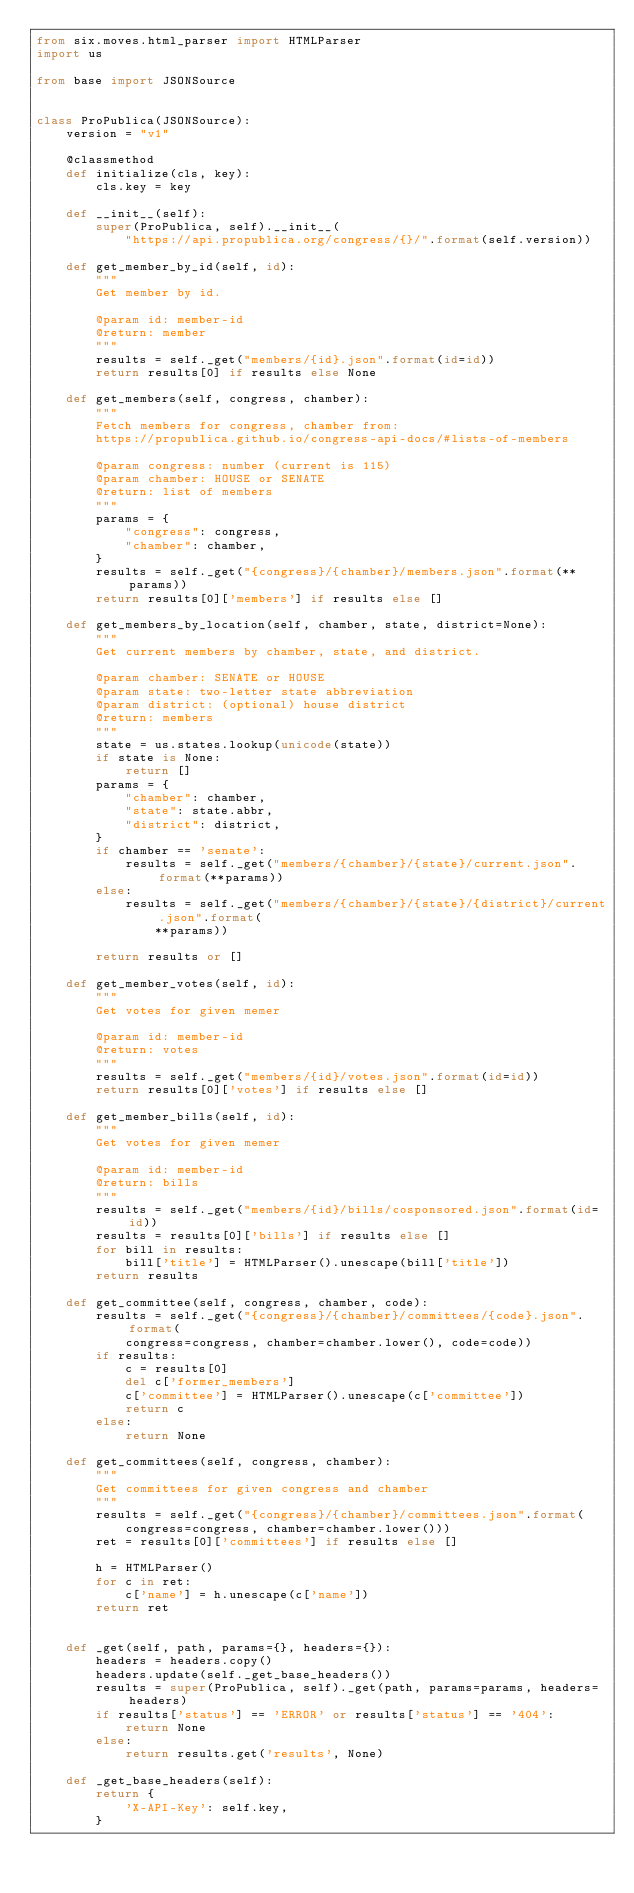Convert code to text. <code><loc_0><loc_0><loc_500><loc_500><_Python_>from six.moves.html_parser import HTMLParser
import us

from base import JSONSource


class ProPublica(JSONSource):
    version = "v1"

    @classmethod
    def initialize(cls, key):
        cls.key = key

    def __init__(self):
        super(ProPublica, self).__init__(
            "https://api.propublica.org/congress/{}/".format(self.version))

    def get_member_by_id(self, id):
        """
        Get member by id.

        @param id: member-id
        @return: member
        """
        results = self._get("members/{id}.json".format(id=id))
        return results[0] if results else None

    def get_members(self, congress, chamber):
        """
        Fetch members for congress, chamber from:
        https://propublica.github.io/congress-api-docs/#lists-of-members

        @param congress: number (current is 115)
        @param chamber: HOUSE or SENATE
        @return: list of members
        """
        params = {
            "congress": congress,
            "chamber": chamber,
        }
        results = self._get("{congress}/{chamber}/members.json".format(**params))
        return results[0]['members'] if results else []

    def get_members_by_location(self, chamber, state, district=None):
        """
        Get current members by chamber, state, and district.

        @param chamber: SENATE or HOUSE
        @param state: two-letter state abbreviation
        @param district: (optional) house district
        @return: members
        """
        state = us.states.lookup(unicode(state))
        if state is None:
            return []
        params = {
            "chamber": chamber,
            "state": state.abbr,
            "district": district,
        }
        if chamber == 'senate':
            results = self._get("members/{chamber}/{state}/current.json".format(**params))
        else:
            results = self._get("members/{chamber}/{state}/{district}/current.json".format(
                **params))

        return results or []

    def get_member_votes(self, id):
        """
        Get votes for given memer

        @param id: member-id
        @return: votes
        """
        results = self._get("members/{id}/votes.json".format(id=id))
        return results[0]['votes'] if results else []

    def get_member_bills(self, id):
        """
        Get votes for given memer

        @param id: member-id
        @return: bills
        """
        results = self._get("members/{id}/bills/cosponsored.json".format(id=id))
        results = results[0]['bills'] if results else []
        for bill in results:
            bill['title'] = HTMLParser().unescape(bill['title'])
        return results

    def get_committee(self, congress, chamber, code):
        results = self._get("{congress}/{chamber}/committees/{code}.json".format(
            congress=congress, chamber=chamber.lower(), code=code))
        if results:
            c = results[0]
            del c['former_members']
            c['committee'] = HTMLParser().unescape(c['committee'])
            return c
        else:
            return None

    def get_committees(self, congress, chamber):
        """
        Get committees for given congress and chamber
        """
        results = self._get("{congress}/{chamber}/committees.json".format(
            congress=congress, chamber=chamber.lower()))
        ret = results[0]['committees'] if results else []

        h = HTMLParser()
        for c in ret:
            c['name'] = h.unescape(c['name'])
        return ret


    def _get(self, path, params={}, headers={}):
        headers = headers.copy()
        headers.update(self._get_base_headers())
        results = super(ProPublica, self)._get(path, params=params, headers=headers)
        if results['status'] == 'ERROR' or results['status'] == '404':
            return None
        else:
            return results.get('results', None)

    def _get_base_headers(self):
        return {
            'X-API-Key': self.key,
        }

</code> 